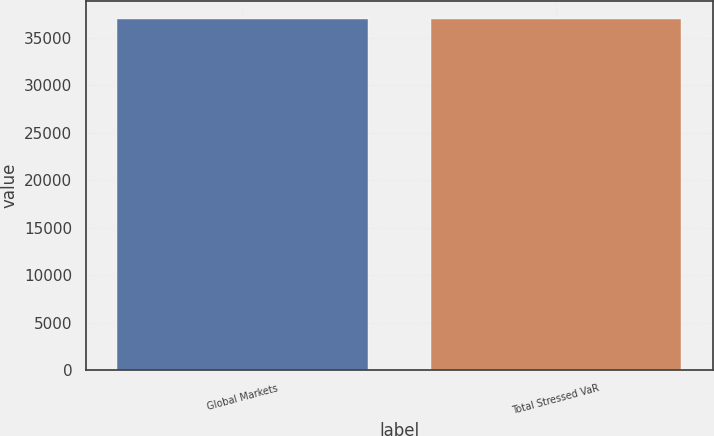Convert chart. <chart><loc_0><loc_0><loc_500><loc_500><bar_chart><fcel>Global Markets<fcel>Total Stressed VaR<nl><fcel>37030<fcel>36949<nl></chart> 